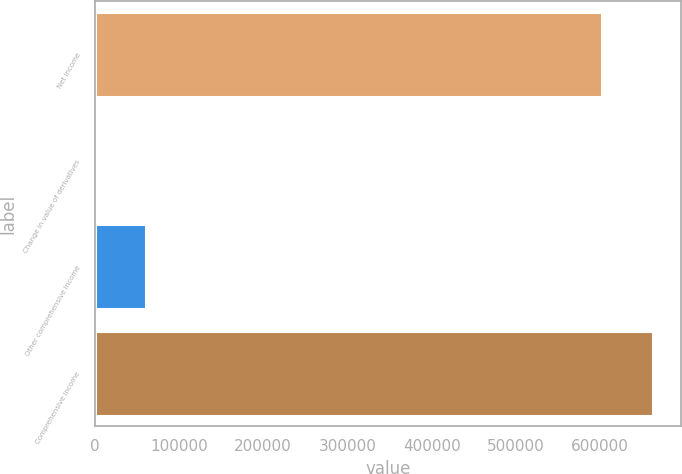Convert chart. <chart><loc_0><loc_0><loc_500><loc_500><bar_chart><fcel>Net income<fcel>Change in value of derivatives<fcel>Other comprehensive income<fcel>Comprehensive income<nl><fcel>602703<fcel>83<fcel>60353.3<fcel>662973<nl></chart> 